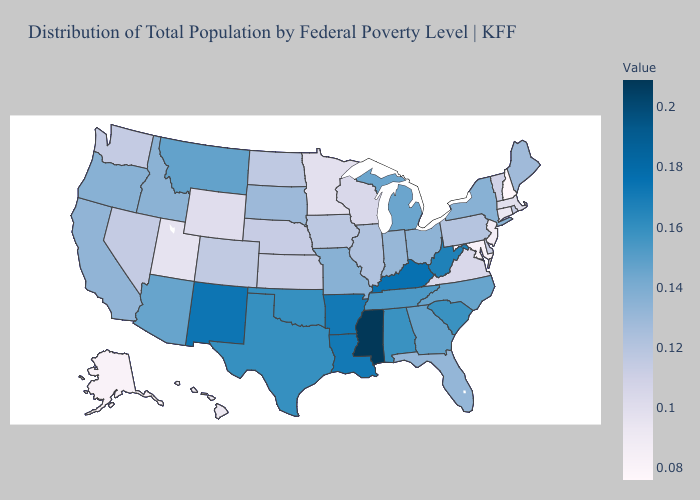Does Arkansas have the lowest value in the USA?
Answer briefly. No. Which states hav the highest value in the MidWest?
Quick response, please. Michigan. Does Utah have the lowest value in the West?
Keep it brief. No. Which states have the highest value in the USA?
Be succinct. Mississippi. Among the states that border South Carolina , which have the highest value?
Keep it brief. Georgia. Does New Hampshire have the lowest value in the USA?
Short answer required. Yes. Which states have the lowest value in the West?
Concise answer only. Alaska. 